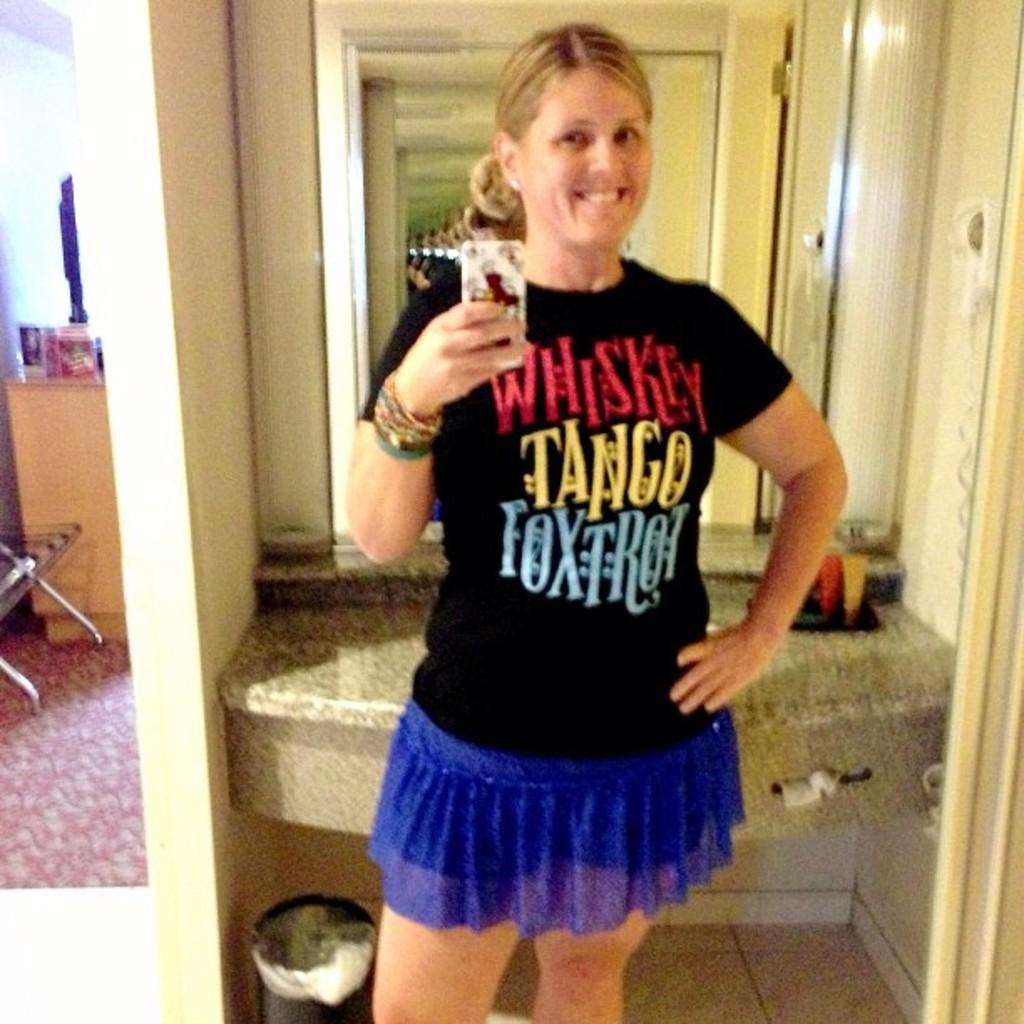<image>
Relay a brief, clear account of the picture shown. A woman wears a blue skirt and a T shirt that says, "Whiskey Tango Foxtrot." 